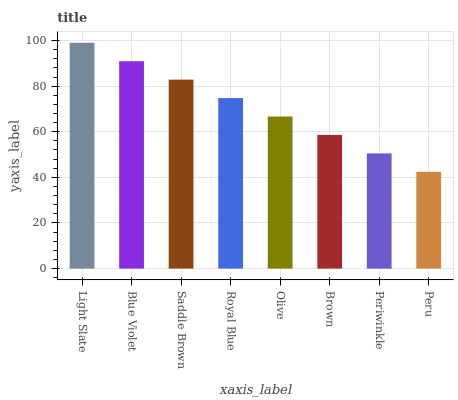Is Blue Violet the minimum?
Answer yes or no. No. Is Blue Violet the maximum?
Answer yes or no. No. Is Light Slate greater than Blue Violet?
Answer yes or no. Yes. Is Blue Violet less than Light Slate?
Answer yes or no. Yes. Is Blue Violet greater than Light Slate?
Answer yes or no. No. Is Light Slate less than Blue Violet?
Answer yes or no. No. Is Royal Blue the high median?
Answer yes or no. Yes. Is Olive the low median?
Answer yes or no. Yes. Is Olive the high median?
Answer yes or no. No. Is Brown the low median?
Answer yes or no. No. 